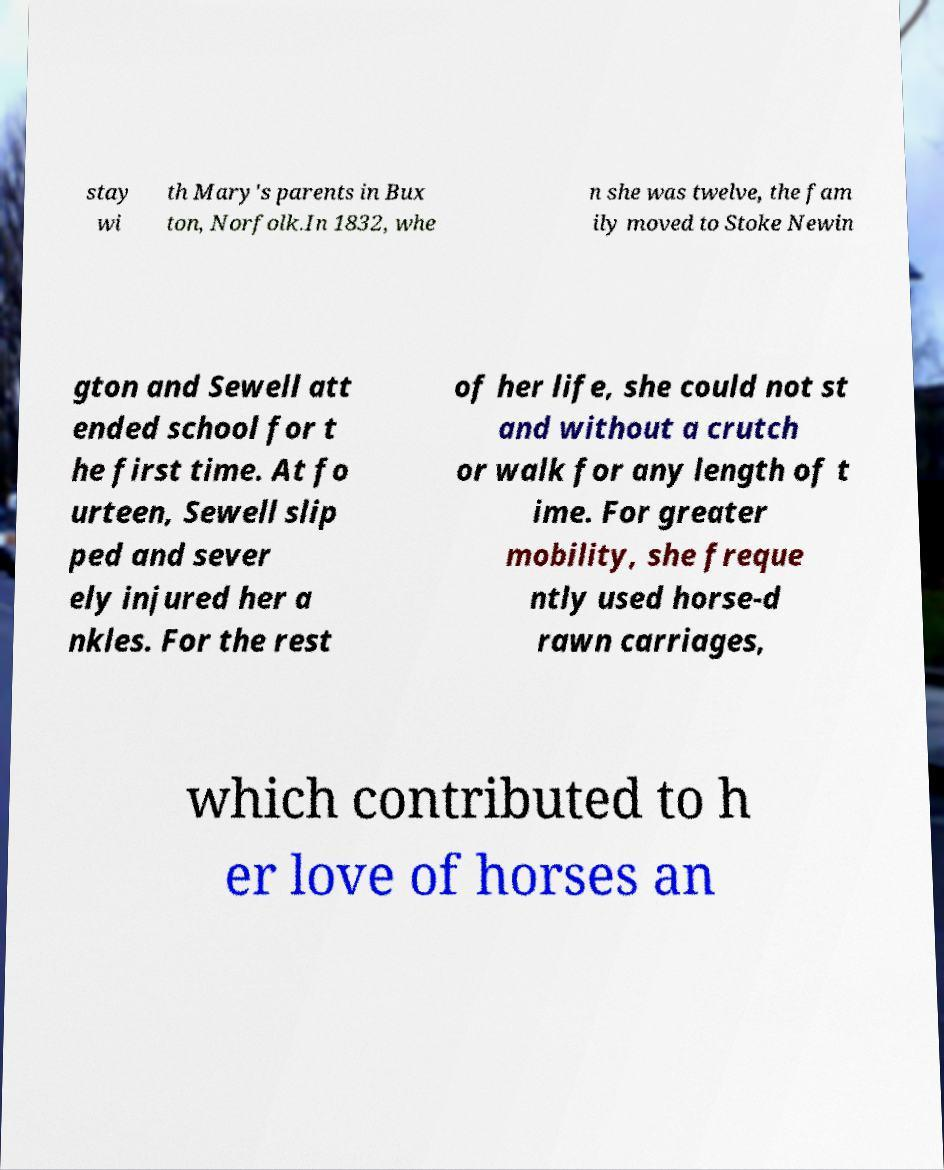For documentation purposes, I need the text within this image transcribed. Could you provide that? stay wi th Mary's parents in Bux ton, Norfolk.In 1832, whe n she was twelve, the fam ily moved to Stoke Newin gton and Sewell att ended school for t he first time. At fo urteen, Sewell slip ped and sever ely injured her a nkles. For the rest of her life, she could not st and without a crutch or walk for any length of t ime. For greater mobility, she freque ntly used horse-d rawn carriages, which contributed to h er love of horses an 